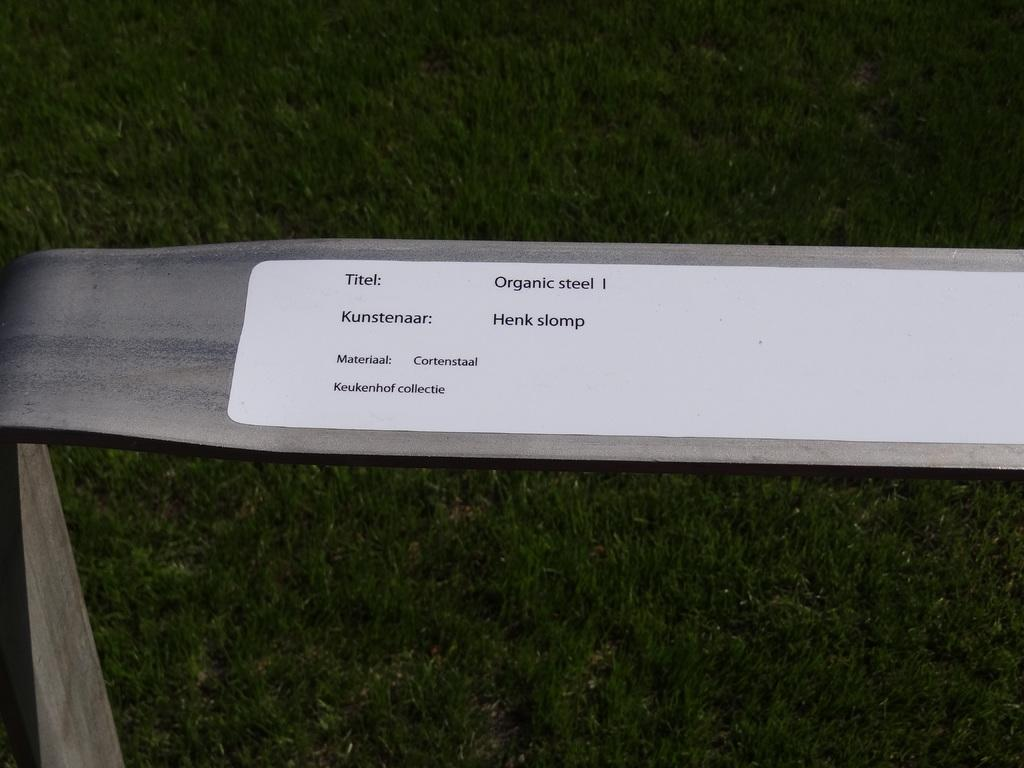What material is the object in the image made of? The object in the image is made of steel. Is there any additional detail on the object? Yes, there is a sticker on the object. Can you see any scissors cutting through the window in the image? There is no window or scissors present in the image. 